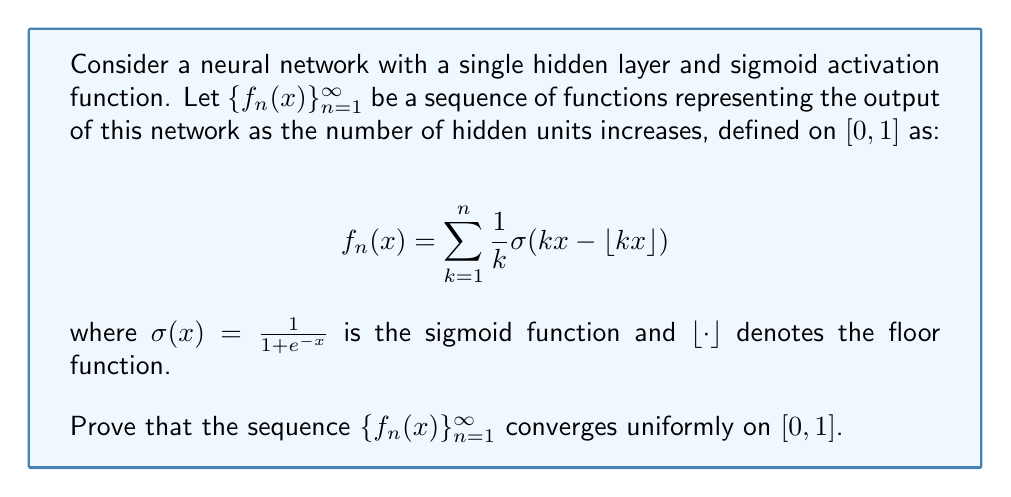Give your solution to this math problem. To prove uniform convergence, we'll use the Weierstrass M-test. The steps are as follows:

1) First, we need to show that the series $\sum_{k=1}^{\infty} \frac{1}{k} \sigma(kx - \lfloor kx \rfloor)$ is absolutely convergent.

2) Observe that $0 \leq kx - \lfloor kx \rfloor < 1$ for all $x \in [0,1]$ and $k \in \mathbb{N}$.

3) The sigmoid function $\sigma(x)$ is increasing and bounded: $0 < \sigma(x) < 1$ for all $x \in \mathbb{R}$.

4) Therefore, $0 < \sigma(kx - \lfloor kx \rfloor) < \sigma(1)$ for all $x \in [0,1]$ and $k \in \mathbb{N}$.

5) Let $M_k = \frac{1}{k} \sigma(1)$. Then $|\frac{1}{k} \sigma(kx - \lfloor kx \rfloor)| \leq M_k$ for all $x \in [0,1]$ and $k \in \mathbb{N}$.

6) The series $\sum_{k=1}^{\infty} M_k = \sigma(1) \sum_{k=1}^{\infty} \frac{1}{k}$ is the harmonic series multiplied by a constant. This series diverges.

7) However, we can use the comparison test with $\sum_{k=1}^{\infty} \frac{1}{k^{1+\epsilon}}$ for any $\epsilon > 0$, which converges.

8) Choose $\epsilon = 0.1$. Then $\sum_{k=1}^{\infty} \frac{1}{k^{1.1}}$ converges, and $\frac{1}{k} \sigma(1) \leq \frac{1}{k^{1.1}}$ for sufficiently large $k$.

9) By the comparison test, $\sum_{k=1}^{\infty} M_k$ converges.

10) Therefore, by the Weierstrass M-test, the series $\sum_{k=1}^{\infty} \frac{1}{k} \sigma(kx - \lfloor kx \rfloor)$ converges uniformly on $[0,1]$.

11) This implies that the sequence of partial sums $\{f_n(x)\}_{n=1}^{\infty}$ converges uniformly on $[0,1]$.
Answer: The sequence $\{f_n(x)\}_{n=1}^{\infty}$ converges uniformly on $[0,1]$. This is proven using the Weierstrass M-test, showing that $\sum_{k=1}^{\infty} \frac{1}{k} \sigma(kx - \lfloor kx \rfloor)$ is absolutely and uniformly convergent on $[0,1]$. 